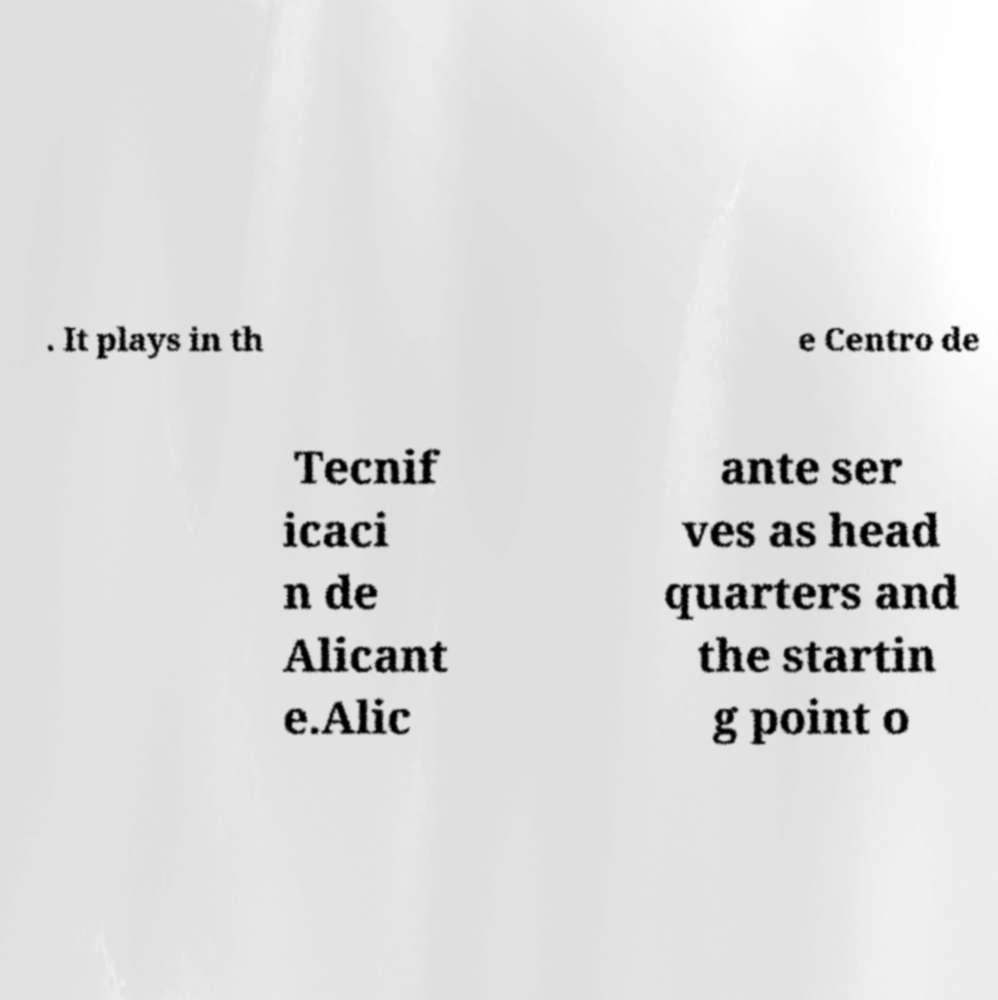I need the written content from this picture converted into text. Can you do that? . It plays in th e Centro de Tecnif icaci n de Alicant e.Alic ante ser ves as head quarters and the startin g point o 